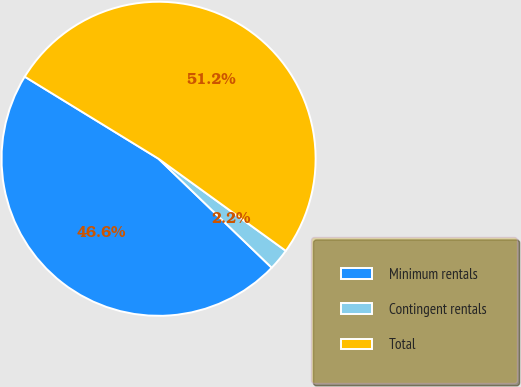Convert chart to OTSL. <chart><loc_0><loc_0><loc_500><loc_500><pie_chart><fcel>Minimum rentals<fcel>Contingent rentals<fcel>Total<nl><fcel>46.56%<fcel>2.23%<fcel>51.21%<nl></chart> 